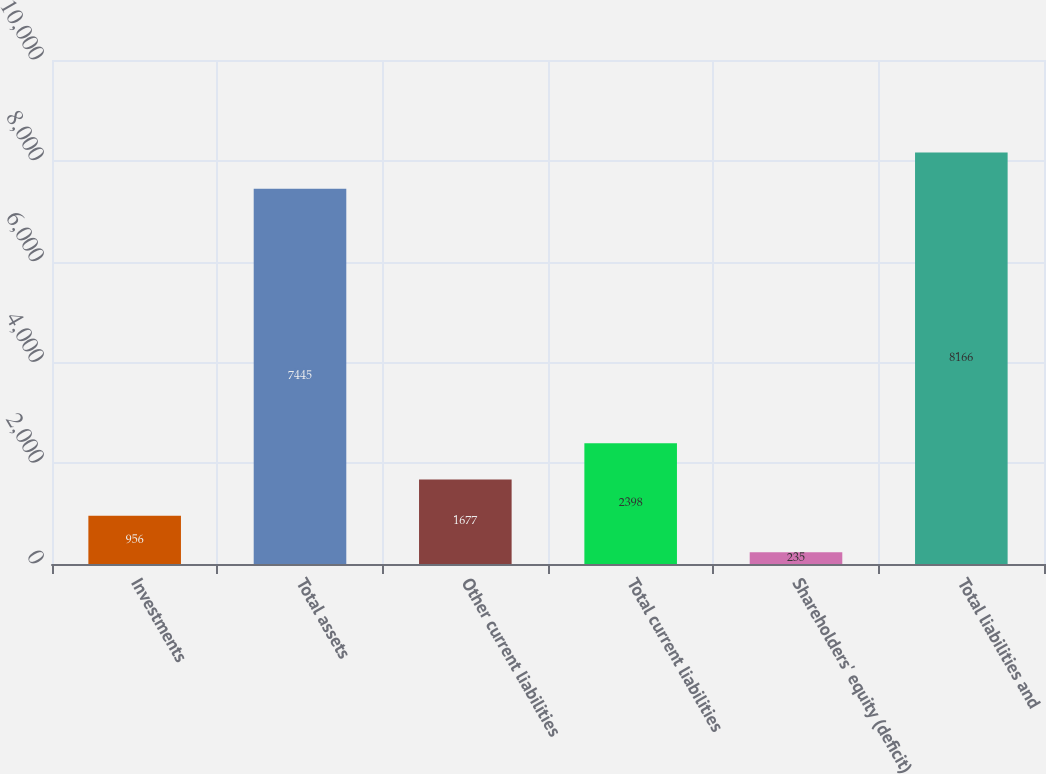Convert chart to OTSL. <chart><loc_0><loc_0><loc_500><loc_500><bar_chart><fcel>Investments<fcel>Total assets<fcel>Other current liabilities<fcel>Total current liabilities<fcel>Shareholders' equity (deficit)<fcel>Total liabilities and<nl><fcel>956<fcel>7445<fcel>1677<fcel>2398<fcel>235<fcel>8166<nl></chart> 